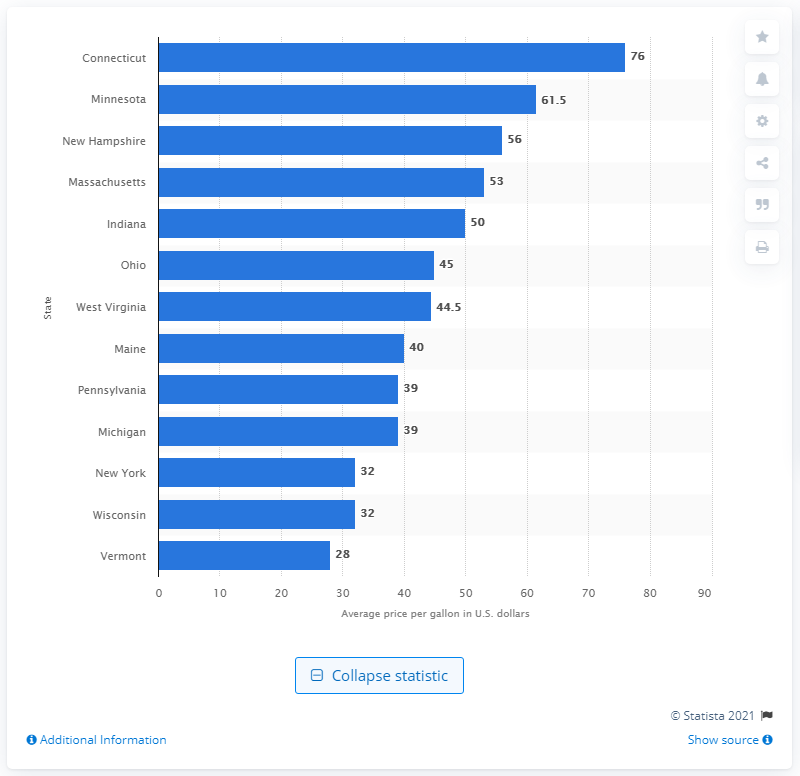Specify some key components in this picture. Maple syrup prices varied by state, with the highest average price per gallon in Connecticut. Minnesota had the second highest average price per gallon of maple syrup. 